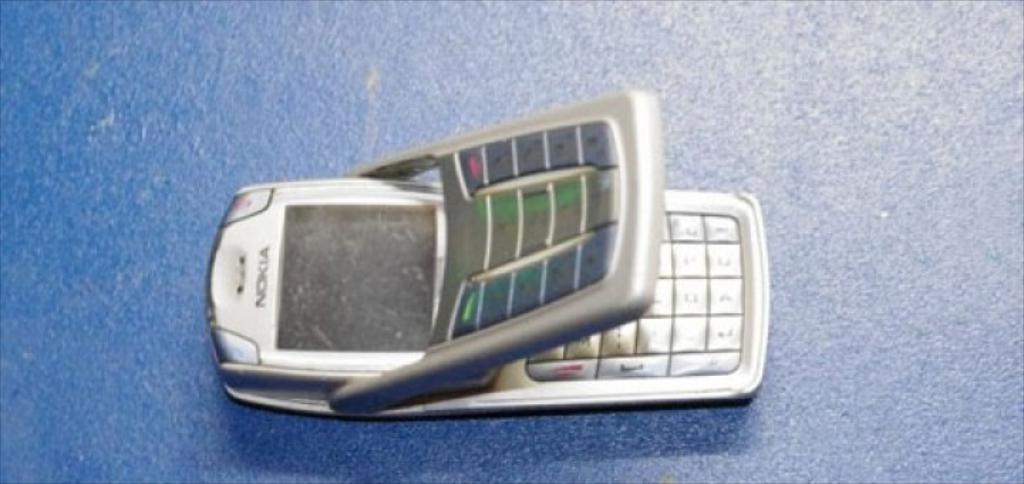What brand is this phone?
Make the answer very short. Nokia. Is the nokia a flip phone?
Your response must be concise. Yes. 